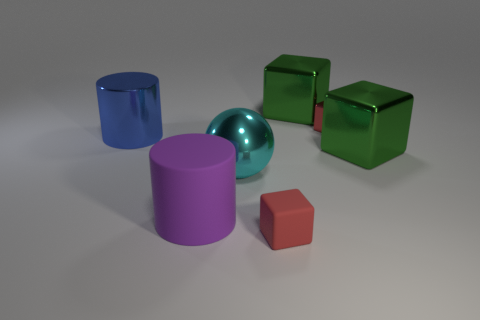How many cubes are either big shiny objects or cyan things?
Your answer should be very brief. 2. How many big things are both right of the purple object and left of the red matte cube?
Offer a very short reply. 1. How many other objects are there of the same color as the large sphere?
Your answer should be compact. 0. What is the shape of the large green metallic object that is behind the tiny metallic block?
Make the answer very short. Cube. Is the material of the large cyan ball the same as the big blue cylinder?
Offer a terse response. Yes. How many metallic cubes are behind the small shiny cube?
Make the answer very short. 1. What is the shape of the big green thing that is in front of the big thing left of the matte cylinder?
Give a very brief answer. Cube. Is there any other thing that has the same shape as the cyan metal object?
Your response must be concise. No. Are there more big blue cylinders left of the small red metal block than brown spheres?
Make the answer very short. Yes. What number of blue things are on the left side of the metal object behind the red metal block?
Provide a short and direct response. 1. 